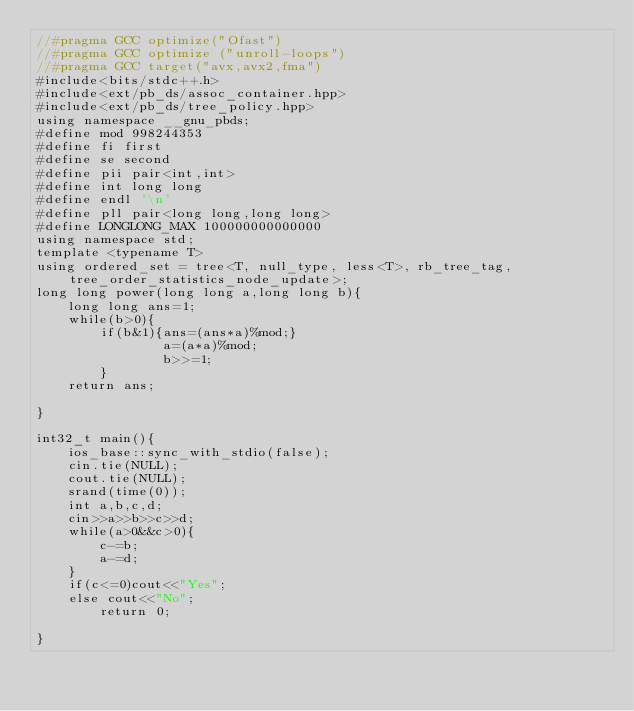Convert code to text. <code><loc_0><loc_0><loc_500><loc_500><_C_>//#pragma GCC optimize("Ofast")
//#pragma GCC optimize ("unroll-loops")
//#pragma GCC target("avx,avx2,fma")
#include<bits/stdc++.h>
#include<ext/pb_ds/assoc_container.hpp>
#include<ext/pb_ds/tree_policy.hpp>
using namespace __gnu_pbds;
#define mod 998244353
#define fi first
#define se second
#define pii pair<int,int>
#define int long long
#define endl '\n'
#define pll pair<long long,long long>
#define LONGLONG_MAX 100000000000000
using namespace std;
template <typename T>
using ordered_set = tree<T, null_type, less<T>, rb_tree_tag, tree_order_statistics_node_update>;
long long power(long long a,long long b){
    long long ans=1;
    while(b>0){
        if(b&1){ans=(ans*a)%mod;}
                a=(a*a)%mod;
                b>>=1;
        }
    return ans;
        
}

int32_t main(){
    ios_base::sync_with_stdio(false);
    cin.tie(NULL);
    cout.tie(NULL);
    srand(time(0));
    int a,b,c,d;
    cin>>a>>b>>c>>d;
    while(a>0&&c>0){
        c-=b;
        a-=d;
    }
    if(c<=0)cout<<"Yes";
    else cout<<"No";
        return 0;
    
}</code> 